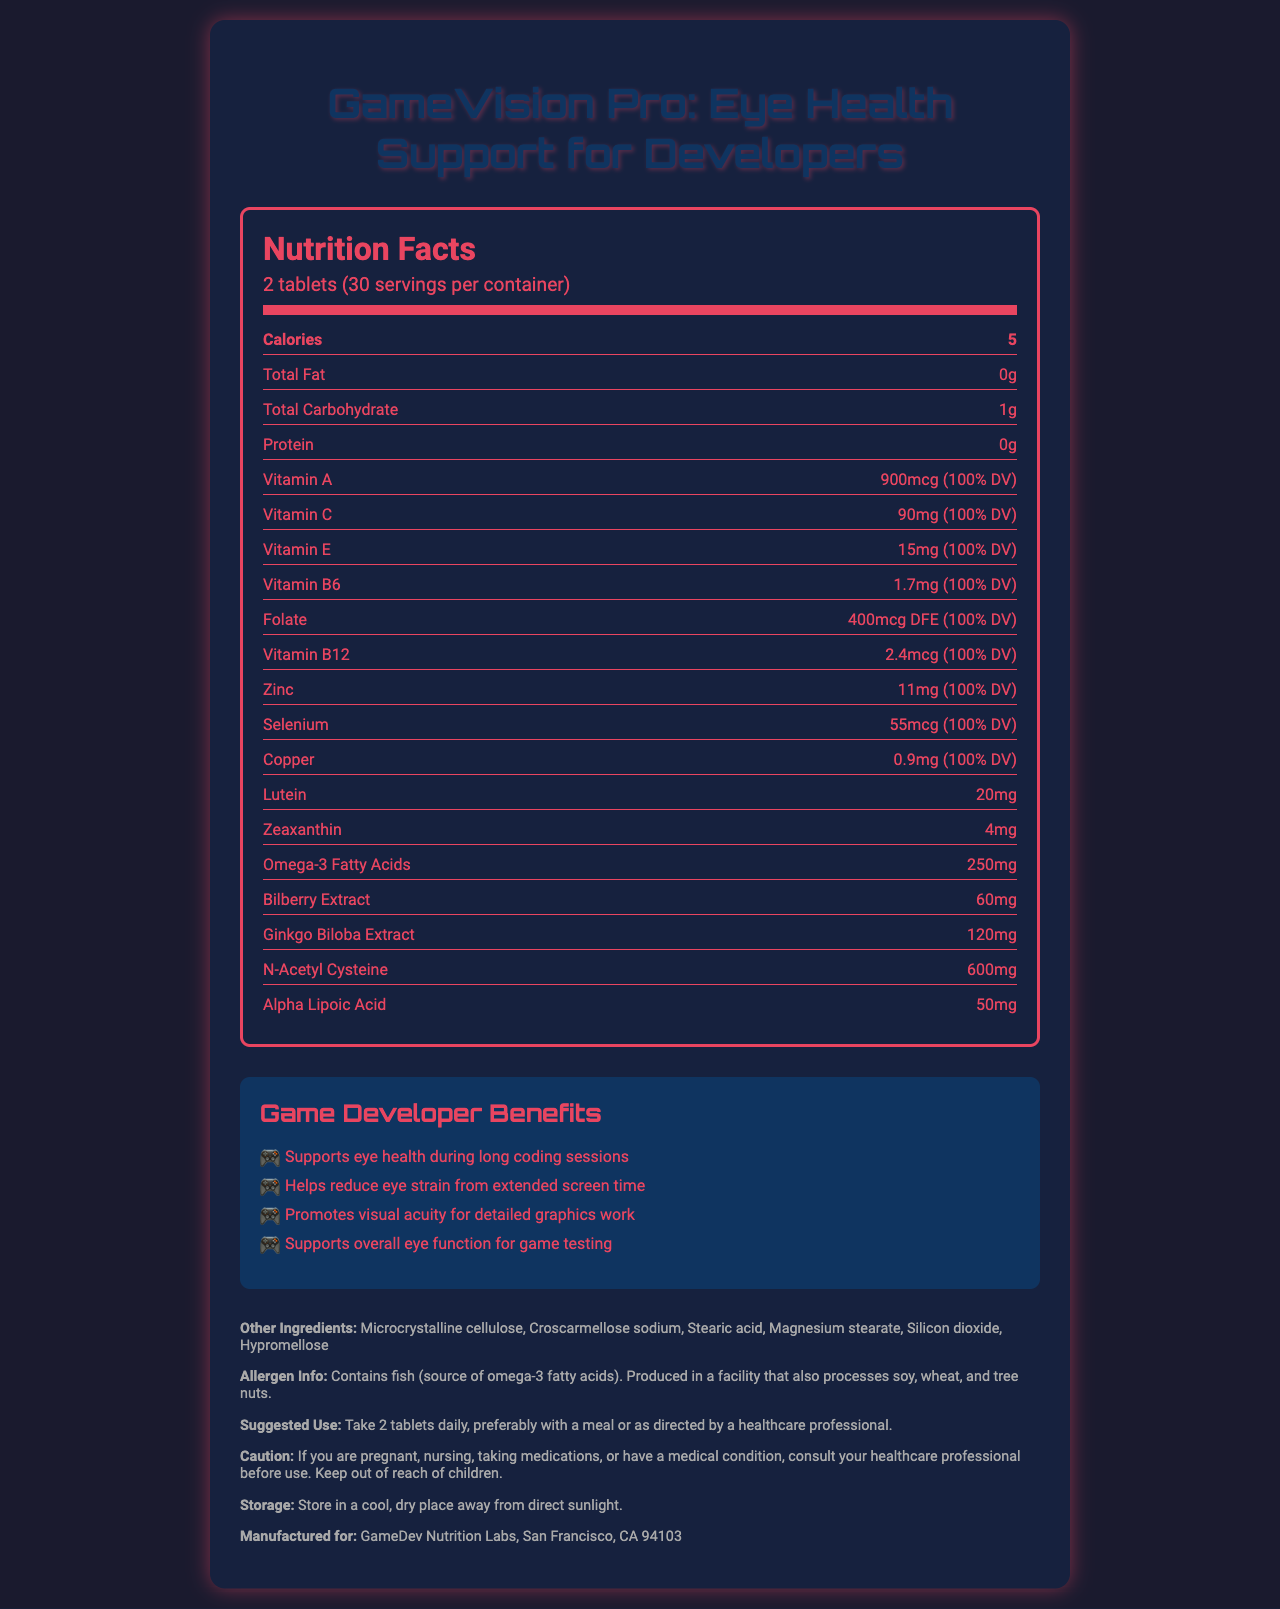what is the serving size of GameVision Pro? The document states that the serving size is 2 tablets.
Answer: 2 tablets how many servings are there per container? The nutrition facts indicate that there are 30 servings per container.
Answer: 30 servings how many calories are in one serving? The document states that there are 5 calories per serving.
Answer: 5 calories how much lutein is in one serving? According to the nutrition facts, one serving contains 20mg of lutein.
Answer: 20mg what is the main benefit of the product for game developers? The benefit mentioned first under the "Game Developer Benefits" section is "Supports eye health during long coding sessions".
Answer: Supports eye health during long coding sessions how much vitamin A does one serving provide? A. 400mcg B. 900mcg C. 600mcg D. 1200mcg The document states that one serving provides 900mcg of Vitamin A.
Answer: B. 900mcg which of the following ingredients is present in the document's other ingredients list? i. Wheat ii. Silicon Dioxide iii. Soy iv. Fish The "Other Ingredients" section lists Silicon Dioxide as one of the ingredients.
Answer: ii. Silicon Dioxide does the supplement contain any fish-derived ingredients? The allergen information mentions that the product contains fish as a source of omega-3 fatty acids.
Answer: Yes summarize the document's main purpose and key points. The document provides comprehensive information on the GameVision Pro supplement, highlighting its vitamin and mineral content, specific benefits for game developers, usage instructions, and ingredient safety considerations.
Answer: The document details the nutrition facts and benefits of "GameVision Pro: Eye Health Support for Developers". It includes information on serving size, primary nutrients and their benefits, targeted support for game developers' eye health, other ingredients, precautionary notes, and allergen information. The supplement supports eye health, reduces eye strain, and enhances visual acuity during extended screen time. how many milligrams of Omega-3 Fatty Acids does one serving contain? The document lists that one serving contains 250mg of Omega-3 Fatty Acids.
Answer: 250mg is this product suitable for those with nut allergies? The allergen info notes that the product is produced in a facility that processes tree nuts; there is no detailed information on whether traces of nuts are present.
Answer: Not enough information who manufactures GameVision Pro? The document states that it is manufactured for GameDev Nutrition Labs, based in San Francisco, CA.
Answer: GameDev Nutrition Labs, San Francisco, CA 94103 what precautions should be taken when using this supplement? The caution section provides these specific precautions.
Answer: If you are pregnant, nursing, taking medications, or have a medical condition, consult your healthcare professional before use. Keep out of reach of children. 